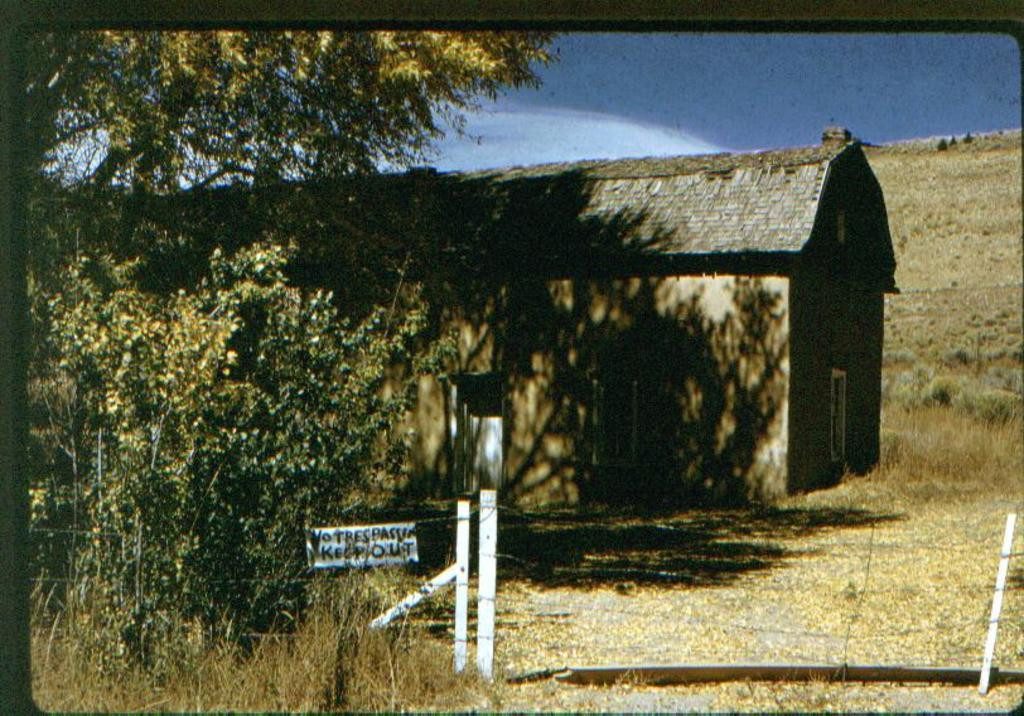What type of structure is present in the image? There is a house in the image. What is on the ground in the image? The ground has dry leaves in the image. What type of vegetation can be seen in the image? There are plants and trees in the image. What type of barrier is present in the image? There is fencing in the image. What is attached to the board in the image? There is a board with text in the image. What is visible in the sky in the image? The sky is visible in the image, and there are clouds in the sky. How many rabbits are playing with a kite in the image? There are no rabbits or kites present in the image. What type of list is visible on the board in the image? There is no list visible on the board in the image; it has text, but not a list. 